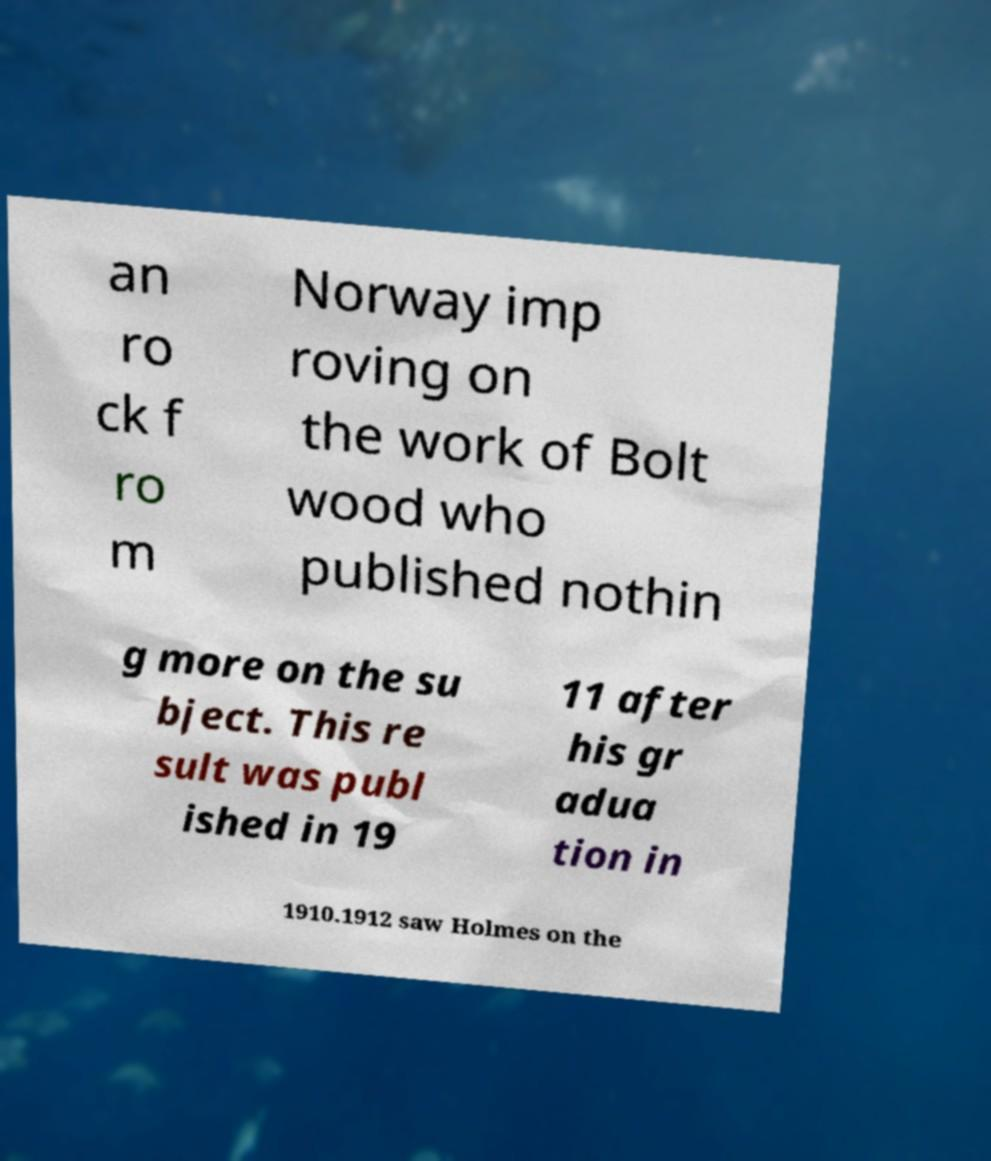For documentation purposes, I need the text within this image transcribed. Could you provide that? an ro ck f ro m Norway imp roving on the work of Bolt wood who published nothin g more on the su bject. This re sult was publ ished in 19 11 after his gr adua tion in 1910.1912 saw Holmes on the 